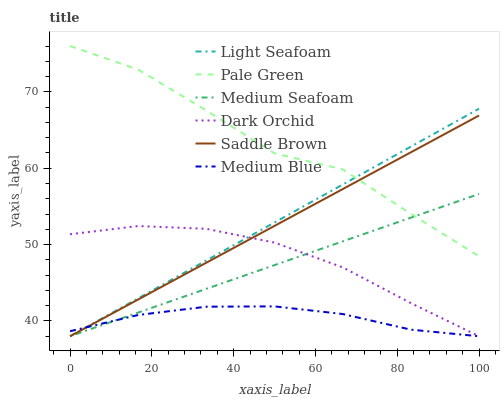Does Medium Blue have the minimum area under the curve?
Answer yes or no. Yes. Does Pale Green have the maximum area under the curve?
Answer yes or no. Yes. Does Dark Orchid have the minimum area under the curve?
Answer yes or no. No. Does Dark Orchid have the maximum area under the curve?
Answer yes or no. No. Is Saddle Brown the smoothest?
Answer yes or no. Yes. Is Pale Green the roughest?
Answer yes or no. Yes. Is Dark Orchid the smoothest?
Answer yes or no. No. Is Dark Orchid the roughest?
Answer yes or no. No. Does Medium Blue have the lowest value?
Answer yes or no. Yes. Does Pale Green have the lowest value?
Answer yes or no. No. Does Pale Green have the highest value?
Answer yes or no. Yes. Does Dark Orchid have the highest value?
Answer yes or no. No. Is Dark Orchid less than Pale Green?
Answer yes or no. Yes. Is Pale Green greater than Dark Orchid?
Answer yes or no. Yes. Does Dark Orchid intersect Medium Seafoam?
Answer yes or no. Yes. Is Dark Orchid less than Medium Seafoam?
Answer yes or no. No. Is Dark Orchid greater than Medium Seafoam?
Answer yes or no. No. Does Dark Orchid intersect Pale Green?
Answer yes or no. No. 